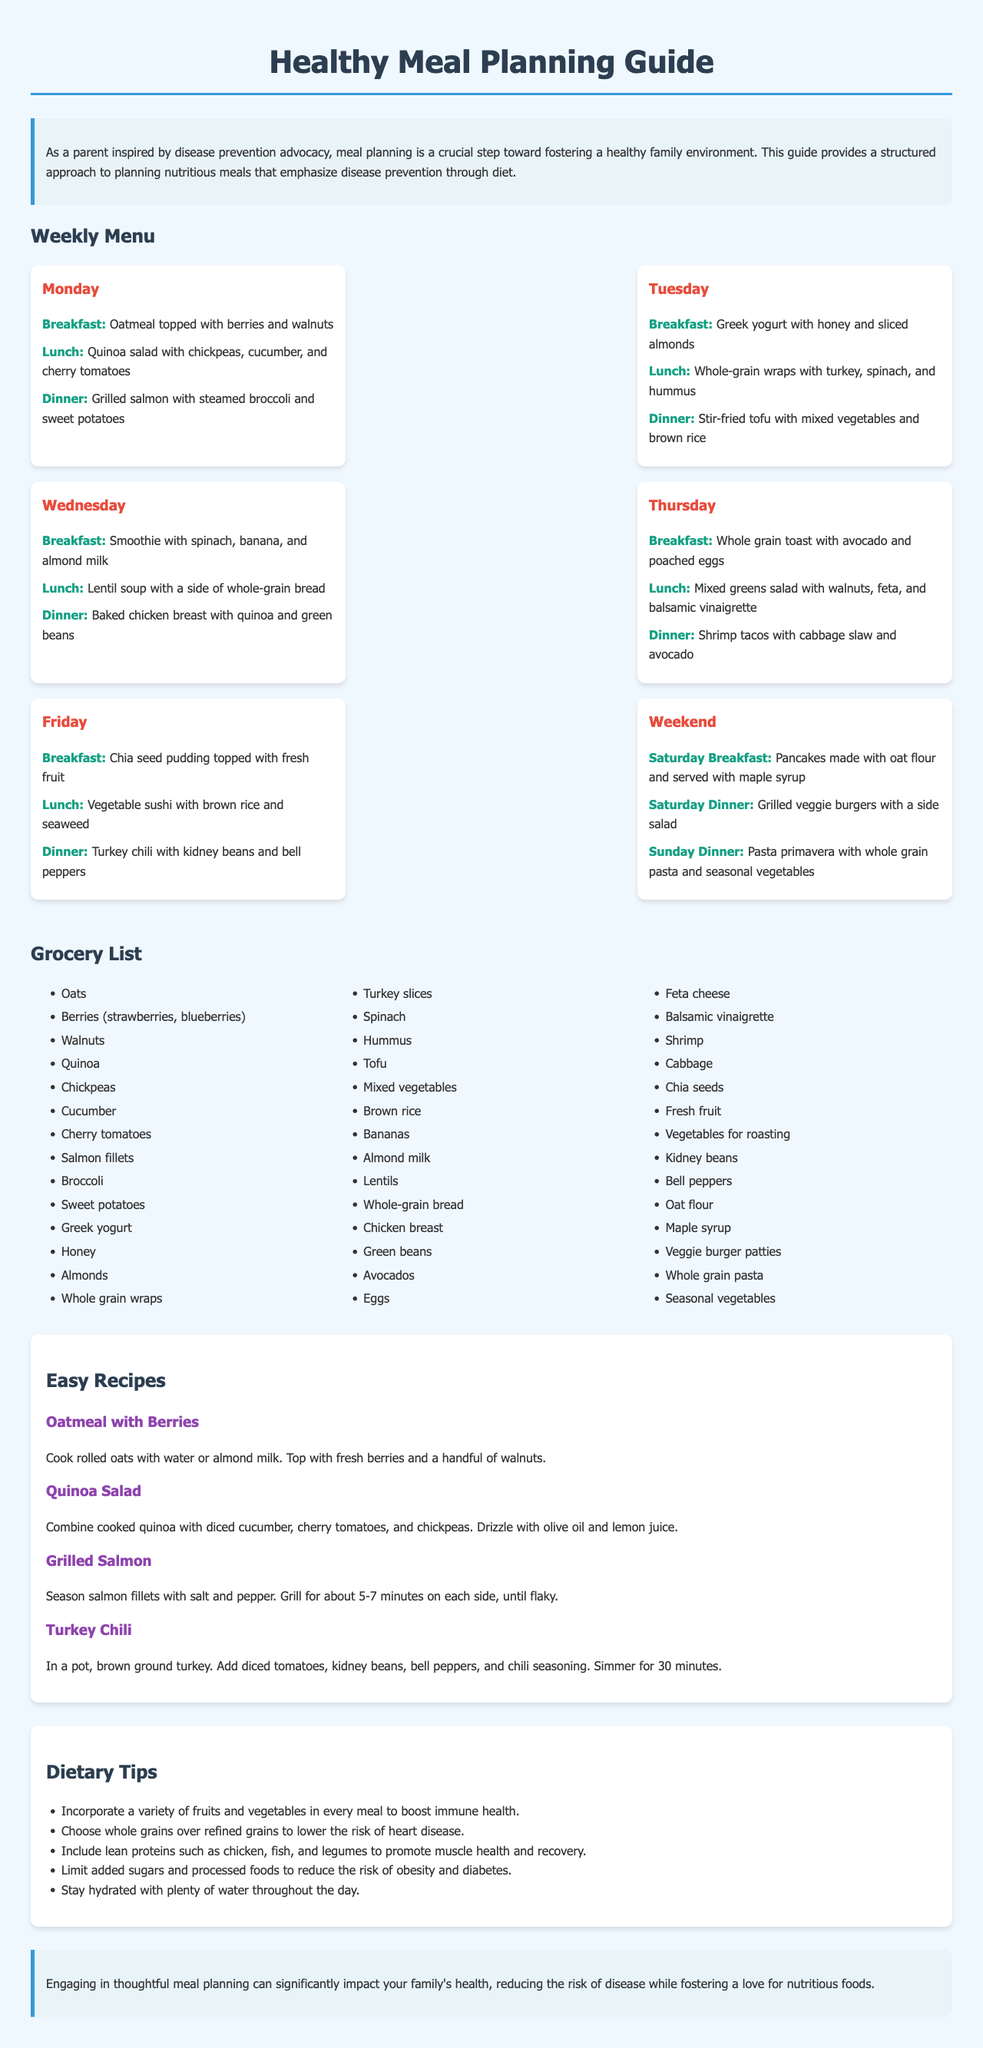What is the title of the document? The title is prominently displayed at the top of the document.
Answer: Healthy Meal Planning Guide How many meals are listed for each day? Each day in the weekly menu lists three meals.
Answer: 3 What is the main focus of this meal planning guide? The introduction clearly states the main focus of the guide.
Answer: Disease prevention through diet Which ingredient is used for breakfast on Monday? The Monday breakfast meal is specifically mentioned in the weekly menu.
Answer: Oatmeal topped with berries and walnuts How many days are included in the weekly menu? The weekly menu is divided into sections, covering specific days.
Answer: 5 What is one of the dietary tips mentioned in the guide? The tips section includes several recommendations for healthy eating.
Answer: Incorporate a variety of fruits and vegetables in every meal What type of recipes are included in the document? The recipes section of the document lists specific types of meals.
Answer: Easy Recipes What type of grocery items are provided in the list? The grocery list includes various food items categorized for meal planning.
Answer: Nutritious foods 